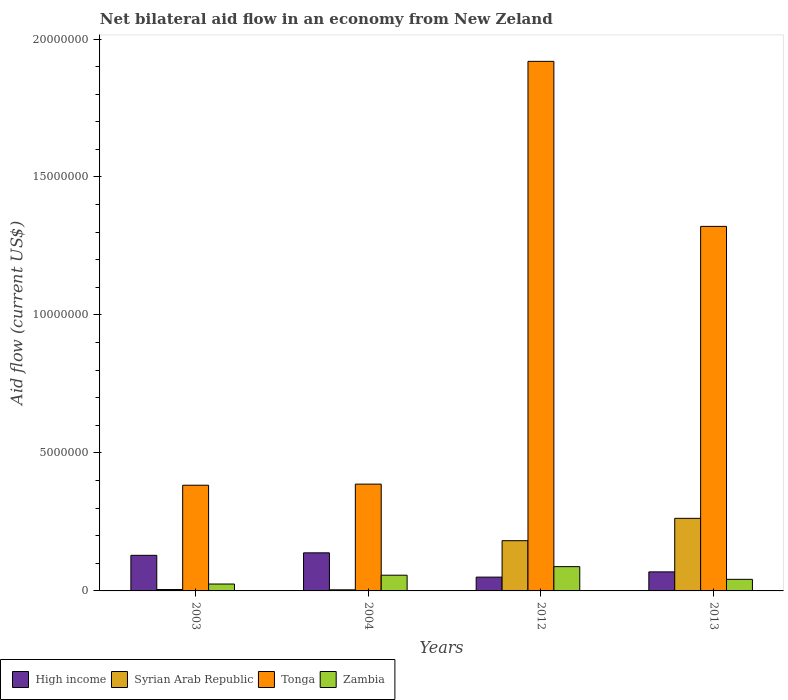How many different coloured bars are there?
Offer a very short reply. 4. How many groups of bars are there?
Offer a terse response. 4. Are the number of bars per tick equal to the number of legend labels?
Make the answer very short. Yes. Are the number of bars on each tick of the X-axis equal?
Offer a terse response. Yes. What is the label of the 1st group of bars from the left?
Provide a succinct answer. 2003. What is the net bilateral aid flow in Tonga in 2003?
Your answer should be compact. 3.83e+06. Across all years, what is the maximum net bilateral aid flow in High income?
Your response must be concise. 1.38e+06. Across all years, what is the minimum net bilateral aid flow in Zambia?
Give a very brief answer. 2.50e+05. In which year was the net bilateral aid flow in Syrian Arab Republic maximum?
Offer a terse response. 2013. In which year was the net bilateral aid flow in Zambia minimum?
Make the answer very short. 2003. What is the total net bilateral aid flow in Tonga in the graph?
Give a very brief answer. 4.01e+07. What is the difference between the net bilateral aid flow in Zambia in 2012 and that in 2013?
Provide a short and direct response. 4.60e+05. What is the difference between the net bilateral aid flow in High income in 2003 and the net bilateral aid flow in Syrian Arab Republic in 2004?
Your answer should be compact. 1.25e+06. What is the average net bilateral aid flow in High income per year?
Provide a short and direct response. 9.65e+05. In the year 2013, what is the difference between the net bilateral aid flow in Tonga and net bilateral aid flow in Zambia?
Provide a short and direct response. 1.28e+07. In how many years, is the net bilateral aid flow in Zambia greater than 9000000 US$?
Provide a succinct answer. 0. What is the ratio of the net bilateral aid flow in Tonga in 2003 to that in 2004?
Give a very brief answer. 0.99. Is the difference between the net bilateral aid flow in Tonga in 2012 and 2013 greater than the difference between the net bilateral aid flow in Zambia in 2012 and 2013?
Provide a short and direct response. Yes. What is the difference between the highest and the second highest net bilateral aid flow in Tonga?
Offer a very short reply. 5.98e+06. What is the difference between the highest and the lowest net bilateral aid flow in High income?
Your response must be concise. 8.80e+05. In how many years, is the net bilateral aid flow in Syrian Arab Republic greater than the average net bilateral aid flow in Syrian Arab Republic taken over all years?
Offer a very short reply. 2. Is the sum of the net bilateral aid flow in High income in 2003 and 2012 greater than the maximum net bilateral aid flow in Tonga across all years?
Make the answer very short. No. What does the 2nd bar from the left in 2013 represents?
Ensure brevity in your answer.  Syrian Arab Republic. What does the 4th bar from the right in 2013 represents?
Your answer should be compact. High income. How many bars are there?
Your response must be concise. 16. Are all the bars in the graph horizontal?
Keep it short and to the point. No. How many years are there in the graph?
Make the answer very short. 4. Are the values on the major ticks of Y-axis written in scientific E-notation?
Ensure brevity in your answer.  No. Does the graph contain grids?
Give a very brief answer. No. What is the title of the graph?
Give a very brief answer. Net bilateral aid flow in an economy from New Zeland. What is the Aid flow (current US$) of High income in 2003?
Offer a terse response. 1.29e+06. What is the Aid flow (current US$) in Syrian Arab Republic in 2003?
Provide a short and direct response. 5.00e+04. What is the Aid flow (current US$) in Tonga in 2003?
Make the answer very short. 3.83e+06. What is the Aid flow (current US$) in Zambia in 2003?
Provide a succinct answer. 2.50e+05. What is the Aid flow (current US$) in High income in 2004?
Give a very brief answer. 1.38e+06. What is the Aid flow (current US$) of Tonga in 2004?
Your answer should be very brief. 3.87e+06. What is the Aid flow (current US$) of Zambia in 2004?
Your answer should be compact. 5.70e+05. What is the Aid flow (current US$) in Syrian Arab Republic in 2012?
Your answer should be very brief. 1.82e+06. What is the Aid flow (current US$) of Tonga in 2012?
Keep it short and to the point. 1.92e+07. What is the Aid flow (current US$) of Zambia in 2012?
Offer a very short reply. 8.80e+05. What is the Aid flow (current US$) of High income in 2013?
Offer a very short reply. 6.90e+05. What is the Aid flow (current US$) of Syrian Arab Republic in 2013?
Provide a succinct answer. 2.63e+06. What is the Aid flow (current US$) of Tonga in 2013?
Offer a terse response. 1.32e+07. Across all years, what is the maximum Aid flow (current US$) of High income?
Offer a terse response. 1.38e+06. Across all years, what is the maximum Aid flow (current US$) of Syrian Arab Republic?
Give a very brief answer. 2.63e+06. Across all years, what is the maximum Aid flow (current US$) of Tonga?
Provide a succinct answer. 1.92e+07. Across all years, what is the maximum Aid flow (current US$) in Zambia?
Provide a succinct answer. 8.80e+05. Across all years, what is the minimum Aid flow (current US$) of High income?
Your answer should be compact. 5.00e+05. Across all years, what is the minimum Aid flow (current US$) of Tonga?
Give a very brief answer. 3.83e+06. Across all years, what is the minimum Aid flow (current US$) of Zambia?
Make the answer very short. 2.50e+05. What is the total Aid flow (current US$) in High income in the graph?
Your answer should be very brief. 3.86e+06. What is the total Aid flow (current US$) in Syrian Arab Republic in the graph?
Provide a short and direct response. 4.54e+06. What is the total Aid flow (current US$) of Tonga in the graph?
Provide a short and direct response. 4.01e+07. What is the total Aid flow (current US$) of Zambia in the graph?
Provide a short and direct response. 2.12e+06. What is the difference between the Aid flow (current US$) of High income in 2003 and that in 2004?
Ensure brevity in your answer.  -9.00e+04. What is the difference between the Aid flow (current US$) of Zambia in 2003 and that in 2004?
Your answer should be very brief. -3.20e+05. What is the difference between the Aid flow (current US$) of High income in 2003 and that in 2012?
Your answer should be compact. 7.90e+05. What is the difference between the Aid flow (current US$) in Syrian Arab Republic in 2003 and that in 2012?
Offer a terse response. -1.77e+06. What is the difference between the Aid flow (current US$) in Tonga in 2003 and that in 2012?
Your answer should be compact. -1.54e+07. What is the difference between the Aid flow (current US$) in Zambia in 2003 and that in 2012?
Give a very brief answer. -6.30e+05. What is the difference between the Aid flow (current US$) of High income in 2003 and that in 2013?
Offer a very short reply. 6.00e+05. What is the difference between the Aid flow (current US$) of Syrian Arab Republic in 2003 and that in 2013?
Ensure brevity in your answer.  -2.58e+06. What is the difference between the Aid flow (current US$) of Tonga in 2003 and that in 2013?
Provide a succinct answer. -9.38e+06. What is the difference between the Aid flow (current US$) of Zambia in 2003 and that in 2013?
Provide a short and direct response. -1.70e+05. What is the difference between the Aid flow (current US$) of High income in 2004 and that in 2012?
Offer a very short reply. 8.80e+05. What is the difference between the Aid flow (current US$) of Syrian Arab Republic in 2004 and that in 2012?
Offer a very short reply. -1.78e+06. What is the difference between the Aid flow (current US$) in Tonga in 2004 and that in 2012?
Make the answer very short. -1.53e+07. What is the difference between the Aid flow (current US$) of Zambia in 2004 and that in 2012?
Offer a terse response. -3.10e+05. What is the difference between the Aid flow (current US$) of High income in 2004 and that in 2013?
Offer a very short reply. 6.90e+05. What is the difference between the Aid flow (current US$) in Syrian Arab Republic in 2004 and that in 2013?
Offer a very short reply. -2.59e+06. What is the difference between the Aid flow (current US$) of Tonga in 2004 and that in 2013?
Your answer should be very brief. -9.34e+06. What is the difference between the Aid flow (current US$) in Zambia in 2004 and that in 2013?
Ensure brevity in your answer.  1.50e+05. What is the difference between the Aid flow (current US$) of Syrian Arab Republic in 2012 and that in 2013?
Keep it short and to the point. -8.10e+05. What is the difference between the Aid flow (current US$) in Tonga in 2012 and that in 2013?
Make the answer very short. 5.98e+06. What is the difference between the Aid flow (current US$) of High income in 2003 and the Aid flow (current US$) of Syrian Arab Republic in 2004?
Provide a succinct answer. 1.25e+06. What is the difference between the Aid flow (current US$) of High income in 2003 and the Aid flow (current US$) of Tonga in 2004?
Provide a succinct answer. -2.58e+06. What is the difference between the Aid flow (current US$) of High income in 2003 and the Aid flow (current US$) of Zambia in 2004?
Make the answer very short. 7.20e+05. What is the difference between the Aid flow (current US$) of Syrian Arab Republic in 2003 and the Aid flow (current US$) of Tonga in 2004?
Keep it short and to the point. -3.82e+06. What is the difference between the Aid flow (current US$) in Syrian Arab Republic in 2003 and the Aid flow (current US$) in Zambia in 2004?
Your answer should be compact. -5.20e+05. What is the difference between the Aid flow (current US$) of Tonga in 2003 and the Aid flow (current US$) of Zambia in 2004?
Ensure brevity in your answer.  3.26e+06. What is the difference between the Aid flow (current US$) of High income in 2003 and the Aid flow (current US$) of Syrian Arab Republic in 2012?
Offer a terse response. -5.30e+05. What is the difference between the Aid flow (current US$) in High income in 2003 and the Aid flow (current US$) in Tonga in 2012?
Offer a very short reply. -1.79e+07. What is the difference between the Aid flow (current US$) in High income in 2003 and the Aid flow (current US$) in Zambia in 2012?
Make the answer very short. 4.10e+05. What is the difference between the Aid flow (current US$) in Syrian Arab Republic in 2003 and the Aid flow (current US$) in Tonga in 2012?
Provide a short and direct response. -1.91e+07. What is the difference between the Aid flow (current US$) in Syrian Arab Republic in 2003 and the Aid flow (current US$) in Zambia in 2012?
Offer a terse response. -8.30e+05. What is the difference between the Aid flow (current US$) in Tonga in 2003 and the Aid flow (current US$) in Zambia in 2012?
Your response must be concise. 2.95e+06. What is the difference between the Aid flow (current US$) in High income in 2003 and the Aid flow (current US$) in Syrian Arab Republic in 2013?
Keep it short and to the point. -1.34e+06. What is the difference between the Aid flow (current US$) in High income in 2003 and the Aid flow (current US$) in Tonga in 2013?
Offer a terse response. -1.19e+07. What is the difference between the Aid flow (current US$) of High income in 2003 and the Aid flow (current US$) of Zambia in 2013?
Offer a very short reply. 8.70e+05. What is the difference between the Aid flow (current US$) of Syrian Arab Republic in 2003 and the Aid flow (current US$) of Tonga in 2013?
Your answer should be very brief. -1.32e+07. What is the difference between the Aid flow (current US$) in Syrian Arab Republic in 2003 and the Aid flow (current US$) in Zambia in 2013?
Offer a terse response. -3.70e+05. What is the difference between the Aid flow (current US$) in Tonga in 2003 and the Aid flow (current US$) in Zambia in 2013?
Provide a short and direct response. 3.41e+06. What is the difference between the Aid flow (current US$) in High income in 2004 and the Aid flow (current US$) in Syrian Arab Republic in 2012?
Your response must be concise. -4.40e+05. What is the difference between the Aid flow (current US$) in High income in 2004 and the Aid flow (current US$) in Tonga in 2012?
Give a very brief answer. -1.78e+07. What is the difference between the Aid flow (current US$) of High income in 2004 and the Aid flow (current US$) of Zambia in 2012?
Your response must be concise. 5.00e+05. What is the difference between the Aid flow (current US$) of Syrian Arab Republic in 2004 and the Aid flow (current US$) of Tonga in 2012?
Make the answer very short. -1.92e+07. What is the difference between the Aid flow (current US$) of Syrian Arab Republic in 2004 and the Aid flow (current US$) of Zambia in 2012?
Provide a succinct answer. -8.40e+05. What is the difference between the Aid flow (current US$) in Tonga in 2004 and the Aid flow (current US$) in Zambia in 2012?
Offer a terse response. 2.99e+06. What is the difference between the Aid flow (current US$) in High income in 2004 and the Aid flow (current US$) in Syrian Arab Republic in 2013?
Offer a very short reply. -1.25e+06. What is the difference between the Aid flow (current US$) of High income in 2004 and the Aid flow (current US$) of Tonga in 2013?
Your answer should be compact. -1.18e+07. What is the difference between the Aid flow (current US$) of High income in 2004 and the Aid flow (current US$) of Zambia in 2013?
Give a very brief answer. 9.60e+05. What is the difference between the Aid flow (current US$) in Syrian Arab Republic in 2004 and the Aid flow (current US$) in Tonga in 2013?
Provide a short and direct response. -1.32e+07. What is the difference between the Aid flow (current US$) in Syrian Arab Republic in 2004 and the Aid flow (current US$) in Zambia in 2013?
Ensure brevity in your answer.  -3.80e+05. What is the difference between the Aid flow (current US$) in Tonga in 2004 and the Aid flow (current US$) in Zambia in 2013?
Your answer should be very brief. 3.45e+06. What is the difference between the Aid flow (current US$) of High income in 2012 and the Aid flow (current US$) of Syrian Arab Republic in 2013?
Keep it short and to the point. -2.13e+06. What is the difference between the Aid flow (current US$) in High income in 2012 and the Aid flow (current US$) in Tonga in 2013?
Your answer should be compact. -1.27e+07. What is the difference between the Aid flow (current US$) in High income in 2012 and the Aid flow (current US$) in Zambia in 2013?
Your response must be concise. 8.00e+04. What is the difference between the Aid flow (current US$) in Syrian Arab Republic in 2012 and the Aid flow (current US$) in Tonga in 2013?
Give a very brief answer. -1.14e+07. What is the difference between the Aid flow (current US$) in Syrian Arab Republic in 2012 and the Aid flow (current US$) in Zambia in 2013?
Ensure brevity in your answer.  1.40e+06. What is the difference between the Aid flow (current US$) in Tonga in 2012 and the Aid flow (current US$) in Zambia in 2013?
Give a very brief answer. 1.88e+07. What is the average Aid flow (current US$) in High income per year?
Keep it short and to the point. 9.65e+05. What is the average Aid flow (current US$) in Syrian Arab Republic per year?
Ensure brevity in your answer.  1.14e+06. What is the average Aid flow (current US$) in Tonga per year?
Offer a very short reply. 1.00e+07. What is the average Aid flow (current US$) of Zambia per year?
Offer a very short reply. 5.30e+05. In the year 2003, what is the difference between the Aid flow (current US$) of High income and Aid flow (current US$) of Syrian Arab Republic?
Provide a succinct answer. 1.24e+06. In the year 2003, what is the difference between the Aid flow (current US$) of High income and Aid flow (current US$) of Tonga?
Keep it short and to the point. -2.54e+06. In the year 2003, what is the difference between the Aid flow (current US$) in High income and Aid flow (current US$) in Zambia?
Give a very brief answer. 1.04e+06. In the year 2003, what is the difference between the Aid flow (current US$) of Syrian Arab Republic and Aid flow (current US$) of Tonga?
Your response must be concise. -3.78e+06. In the year 2003, what is the difference between the Aid flow (current US$) of Tonga and Aid flow (current US$) of Zambia?
Your answer should be compact. 3.58e+06. In the year 2004, what is the difference between the Aid flow (current US$) in High income and Aid flow (current US$) in Syrian Arab Republic?
Keep it short and to the point. 1.34e+06. In the year 2004, what is the difference between the Aid flow (current US$) of High income and Aid flow (current US$) of Tonga?
Your answer should be compact. -2.49e+06. In the year 2004, what is the difference between the Aid flow (current US$) of High income and Aid flow (current US$) of Zambia?
Your answer should be very brief. 8.10e+05. In the year 2004, what is the difference between the Aid flow (current US$) of Syrian Arab Republic and Aid flow (current US$) of Tonga?
Your answer should be compact. -3.83e+06. In the year 2004, what is the difference between the Aid flow (current US$) of Syrian Arab Republic and Aid flow (current US$) of Zambia?
Offer a very short reply. -5.30e+05. In the year 2004, what is the difference between the Aid flow (current US$) in Tonga and Aid flow (current US$) in Zambia?
Provide a succinct answer. 3.30e+06. In the year 2012, what is the difference between the Aid flow (current US$) in High income and Aid flow (current US$) in Syrian Arab Republic?
Your answer should be compact. -1.32e+06. In the year 2012, what is the difference between the Aid flow (current US$) in High income and Aid flow (current US$) in Tonga?
Provide a short and direct response. -1.87e+07. In the year 2012, what is the difference between the Aid flow (current US$) in High income and Aid flow (current US$) in Zambia?
Keep it short and to the point. -3.80e+05. In the year 2012, what is the difference between the Aid flow (current US$) in Syrian Arab Republic and Aid flow (current US$) in Tonga?
Give a very brief answer. -1.74e+07. In the year 2012, what is the difference between the Aid flow (current US$) in Syrian Arab Republic and Aid flow (current US$) in Zambia?
Give a very brief answer. 9.40e+05. In the year 2012, what is the difference between the Aid flow (current US$) of Tonga and Aid flow (current US$) of Zambia?
Provide a succinct answer. 1.83e+07. In the year 2013, what is the difference between the Aid flow (current US$) in High income and Aid flow (current US$) in Syrian Arab Republic?
Your response must be concise. -1.94e+06. In the year 2013, what is the difference between the Aid flow (current US$) of High income and Aid flow (current US$) of Tonga?
Ensure brevity in your answer.  -1.25e+07. In the year 2013, what is the difference between the Aid flow (current US$) of High income and Aid flow (current US$) of Zambia?
Offer a very short reply. 2.70e+05. In the year 2013, what is the difference between the Aid flow (current US$) of Syrian Arab Republic and Aid flow (current US$) of Tonga?
Your answer should be compact. -1.06e+07. In the year 2013, what is the difference between the Aid flow (current US$) of Syrian Arab Republic and Aid flow (current US$) of Zambia?
Provide a succinct answer. 2.21e+06. In the year 2013, what is the difference between the Aid flow (current US$) of Tonga and Aid flow (current US$) of Zambia?
Give a very brief answer. 1.28e+07. What is the ratio of the Aid flow (current US$) in High income in 2003 to that in 2004?
Provide a short and direct response. 0.93. What is the ratio of the Aid flow (current US$) in Syrian Arab Republic in 2003 to that in 2004?
Your response must be concise. 1.25. What is the ratio of the Aid flow (current US$) in Tonga in 2003 to that in 2004?
Your response must be concise. 0.99. What is the ratio of the Aid flow (current US$) of Zambia in 2003 to that in 2004?
Keep it short and to the point. 0.44. What is the ratio of the Aid flow (current US$) of High income in 2003 to that in 2012?
Your answer should be compact. 2.58. What is the ratio of the Aid flow (current US$) in Syrian Arab Republic in 2003 to that in 2012?
Your answer should be very brief. 0.03. What is the ratio of the Aid flow (current US$) of Tonga in 2003 to that in 2012?
Offer a terse response. 0.2. What is the ratio of the Aid flow (current US$) of Zambia in 2003 to that in 2012?
Provide a succinct answer. 0.28. What is the ratio of the Aid flow (current US$) of High income in 2003 to that in 2013?
Provide a short and direct response. 1.87. What is the ratio of the Aid flow (current US$) of Syrian Arab Republic in 2003 to that in 2013?
Keep it short and to the point. 0.02. What is the ratio of the Aid flow (current US$) of Tonga in 2003 to that in 2013?
Make the answer very short. 0.29. What is the ratio of the Aid flow (current US$) of Zambia in 2003 to that in 2013?
Keep it short and to the point. 0.6. What is the ratio of the Aid flow (current US$) in High income in 2004 to that in 2012?
Your answer should be compact. 2.76. What is the ratio of the Aid flow (current US$) of Syrian Arab Republic in 2004 to that in 2012?
Offer a terse response. 0.02. What is the ratio of the Aid flow (current US$) of Tonga in 2004 to that in 2012?
Your response must be concise. 0.2. What is the ratio of the Aid flow (current US$) of Zambia in 2004 to that in 2012?
Your answer should be compact. 0.65. What is the ratio of the Aid flow (current US$) in High income in 2004 to that in 2013?
Provide a short and direct response. 2. What is the ratio of the Aid flow (current US$) of Syrian Arab Republic in 2004 to that in 2013?
Your answer should be compact. 0.02. What is the ratio of the Aid flow (current US$) in Tonga in 2004 to that in 2013?
Your answer should be very brief. 0.29. What is the ratio of the Aid flow (current US$) in Zambia in 2004 to that in 2013?
Offer a terse response. 1.36. What is the ratio of the Aid flow (current US$) of High income in 2012 to that in 2013?
Your answer should be very brief. 0.72. What is the ratio of the Aid flow (current US$) of Syrian Arab Republic in 2012 to that in 2013?
Provide a succinct answer. 0.69. What is the ratio of the Aid flow (current US$) of Tonga in 2012 to that in 2013?
Your answer should be compact. 1.45. What is the ratio of the Aid flow (current US$) in Zambia in 2012 to that in 2013?
Ensure brevity in your answer.  2.1. What is the difference between the highest and the second highest Aid flow (current US$) of Syrian Arab Republic?
Offer a very short reply. 8.10e+05. What is the difference between the highest and the second highest Aid flow (current US$) of Tonga?
Provide a short and direct response. 5.98e+06. What is the difference between the highest and the lowest Aid flow (current US$) in High income?
Provide a short and direct response. 8.80e+05. What is the difference between the highest and the lowest Aid flow (current US$) of Syrian Arab Republic?
Keep it short and to the point. 2.59e+06. What is the difference between the highest and the lowest Aid flow (current US$) in Tonga?
Provide a short and direct response. 1.54e+07. What is the difference between the highest and the lowest Aid flow (current US$) of Zambia?
Keep it short and to the point. 6.30e+05. 